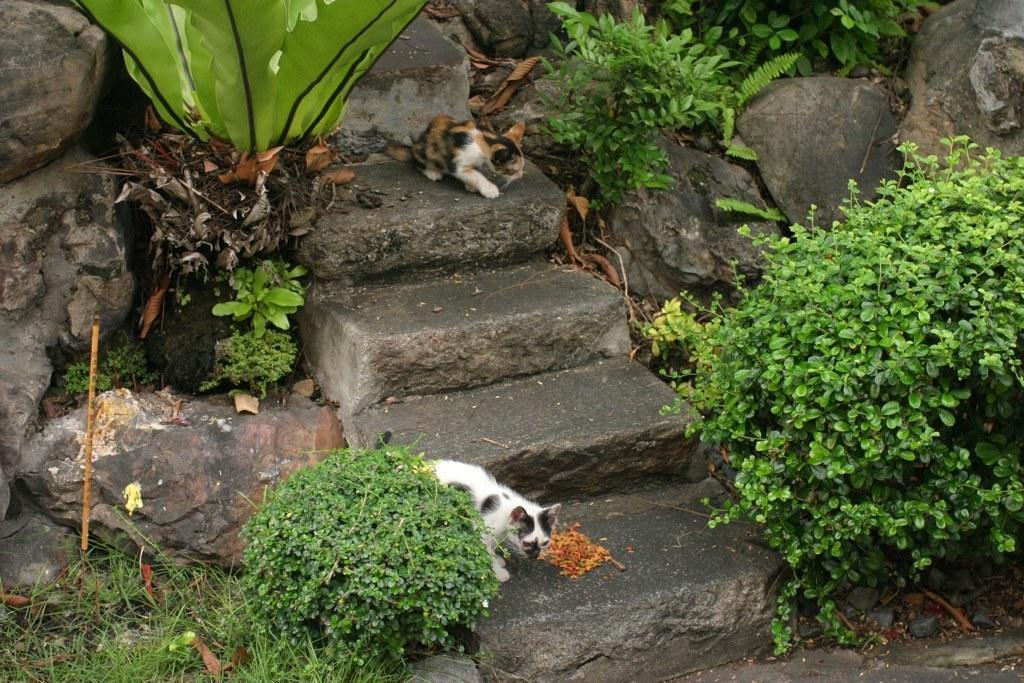Could you give a brief overview of what you see in this image? In this image in the front there are plants and there are cats on the steps. In the background there are stones and there are plants. 